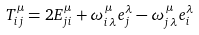Convert formula to latex. <formula><loc_0><loc_0><loc_500><loc_500>T ^ { \mu } _ { i j } = 2 E ^ { \mu } _ { j i } + \omega ^ { \, \mu } _ { i \, \lambda } \/ e ^ { \lambda } _ { j } - \omega ^ { \, \mu } _ { j \, \lambda } \/ e ^ { \lambda } _ { i }</formula> 